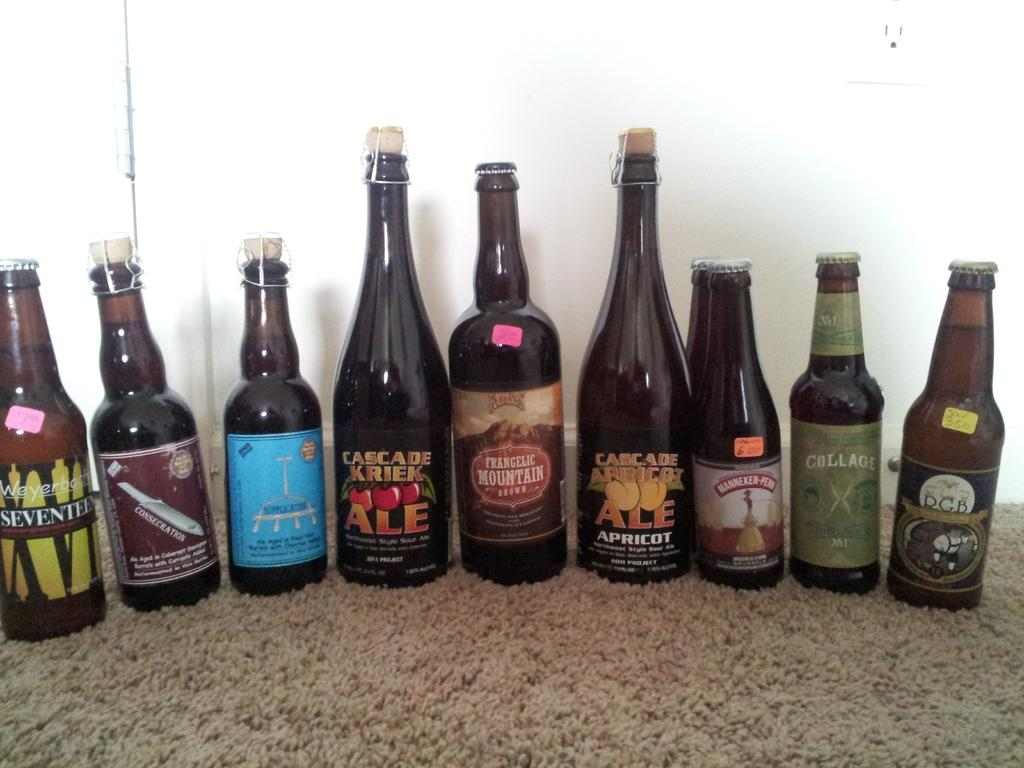<image>
Write a terse but informative summary of the picture. A line of beer bottles includes Frangelic Mountain Brown. 